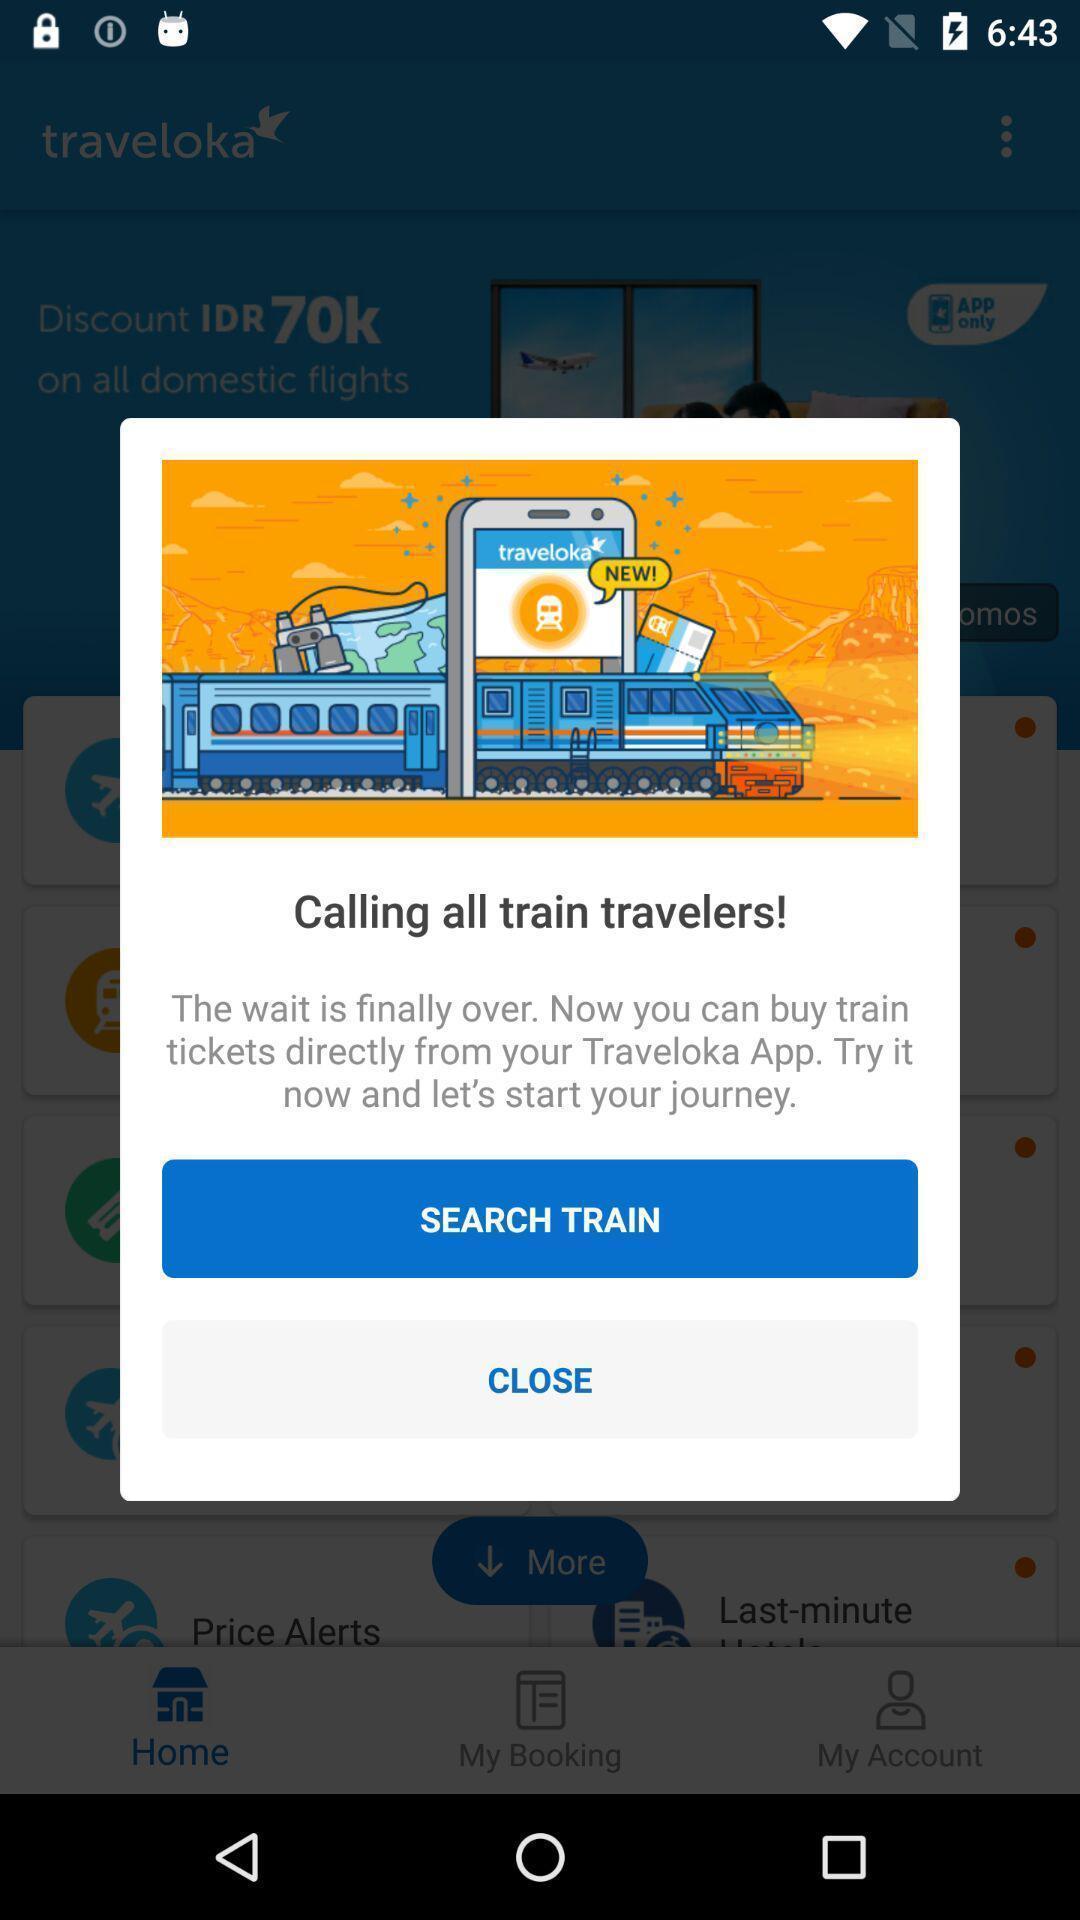Explain the elements present in this screenshot. Pop-up displaying to search train. 